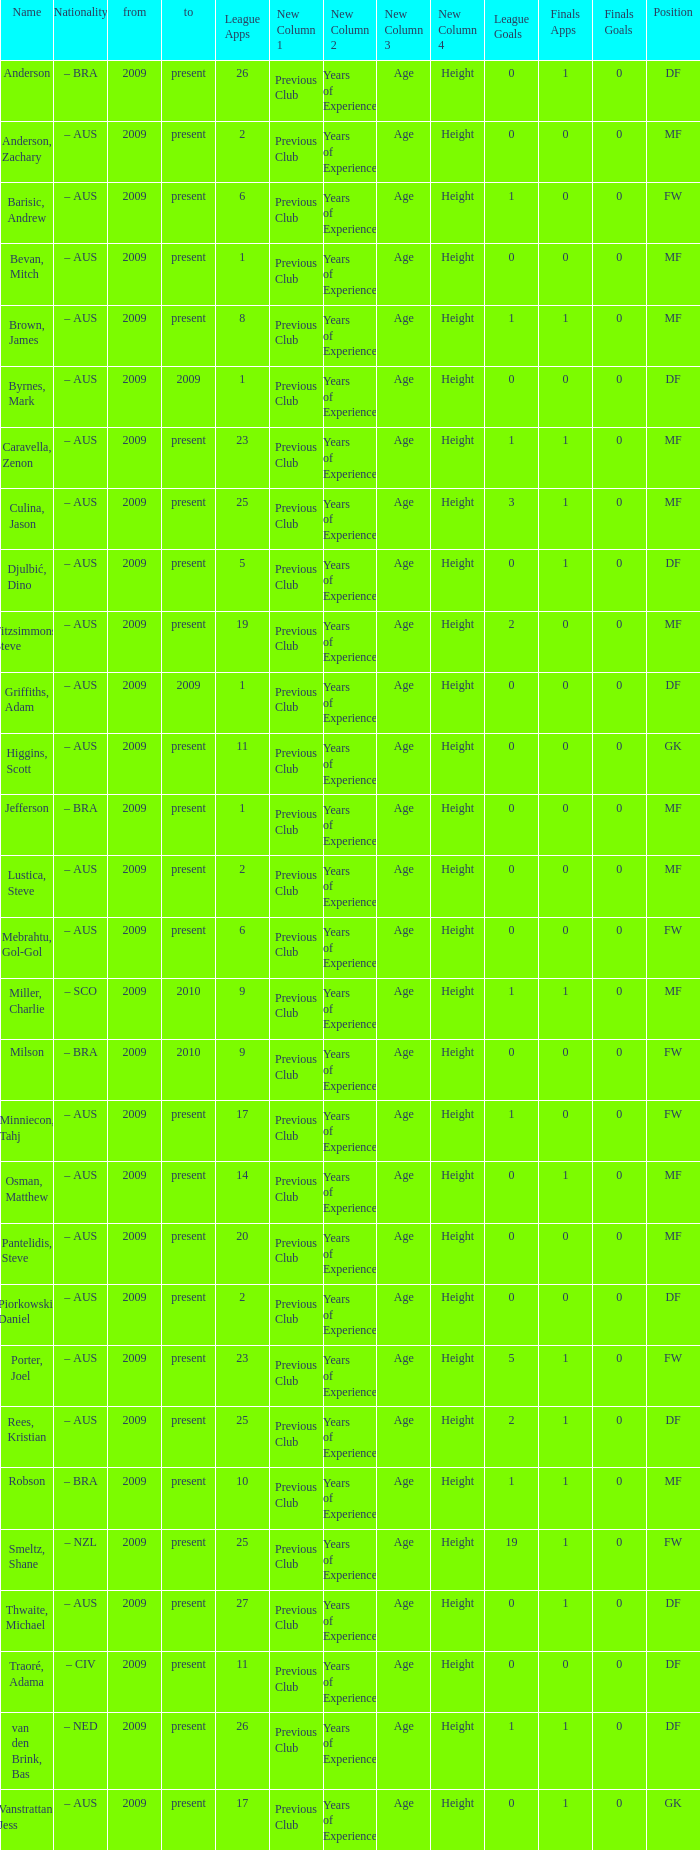Would you mind parsing the complete table? {'header': ['Name', 'Nationality', 'from', 'to', 'League Apps', 'New Column 1', 'New Column 2', 'New Column 3', 'New Column 4', 'League Goals', 'Finals Apps', 'Finals Goals', 'Position'], 'rows': [['Anderson', '– BRA', '2009', 'present', '26', 'Previous Club', 'Years of Experience', 'Age', 'Height', '0', '1', '0', 'DF'], ['Anderson, Zachary', '– AUS', '2009', 'present', '2', 'Previous Club', 'Years of Experience', 'Age', 'Height', '0', '0', '0', 'MF'], ['Barisic, Andrew', '– AUS', '2009', 'present', '6', 'Previous Club', 'Years of Experience', 'Age', 'Height', '1', '0', '0', 'FW'], ['Bevan, Mitch', '– AUS', '2009', 'present', '1', 'Previous Club', 'Years of Experience', 'Age', 'Height', '0', '0', '0', 'MF'], ['Brown, James', '– AUS', '2009', 'present', '8', 'Previous Club', 'Years of Experience', 'Age', 'Height', '1', '1', '0', 'MF'], ['Byrnes, Mark', '– AUS', '2009', '2009', '1', 'Previous Club', 'Years of Experience', 'Age', 'Height', '0', '0', '0', 'DF'], ['Caravella, Zenon', '– AUS', '2009', 'present', '23', 'Previous Club', 'Years of Experience', 'Age', 'Height', '1', '1', '0', 'MF'], ['Culina, Jason', '– AUS', '2009', 'present', '25', 'Previous Club', 'Years of Experience', 'Age', 'Height', '3', '1', '0', 'MF'], ['Djulbić, Dino', '– AUS', '2009', 'present', '5', 'Previous Club', 'Years of Experience', 'Age', 'Height', '0', '1', '0', 'DF'], ['Fitzsimmons, Steve', '– AUS', '2009', 'present', '19', 'Previous Club', 'Years of Experience', 'Age', 'Height', '2', '0', '0', 'MF'], ['Griffiths, Adam', '– AUS', '2009', '2009', '1', 'Previous Club', 'Years of Experience', 'Age', 'Height', '0', '0', '0', 'DF'], ['Higgins, Scott', '– AUS', '2009', 'present', '11', 'Previous Club', 'Years of Experience', 'Age', 'Height', '0', '0', '0', 'GK'], ['Jefferson', '– BRA', '2009', 'present', '1', 'Previous Club', 'Years of Experience', 'Age', 'Height', '0', '0', '0', 'MF'], ['Lustica, Steve', '– AUS', '2009', 'present', '2', 'Previous Club', 'Years of Experience', 'Age', 'Height', '0', '0', '0', 'MF'], ['Mebrahtu, Gol-Gol', '– AUS', '2009', 'present', '6', 'Previous Club', 'Years of Experience', 'Age', 'Height', '0', '0', '0', 'FW'], ['Miller, Charlie', '– SCO', '2009', '2010', '9', 'Previous Club', 'Years of Experience', 'Age', 'Height', '1', '1', '0', 'MF'], ['Milson', '– BRA', '2009', '2010', '9', 'Previous Club', 'Years of Experience', 'Age', 'Height', '0', '0', '0', 'FW'], ['Minniecon, Tahj', '– AUS', '2009', 'present', '17', 'Previous Club', 'Years of Experience', 'Age', 'Height', '1', '0', '0', 'FW'], ['Osman, Matthew', '– AUS', '2009', 'present', '14', 'Previous Club', 'Years of Experience', 'Age', 'Height', '0', '1', '0', 'MF'], ['Pantelidis, Steve', '– AUS', '2009', 'present', '20', 'Previous Club', 'Years of Experience', 'Age', 'Height', '0', '0', '0', 'MF'], ['Piorkowski, Daniel', '– AUS', '2009', 'present', '2', 'Previous Club', 'Years of Experience', 'Age', 'Height', '0', '0', '0', 'DF'], ['Porter, Joel', '– AUS', '2009', 'present', '23', 'Previous Club', 'Years of Experience', 'Age', 'Height', '5', '1', '0', 'FW'], ['Rees, Kristian', '– AUS', '2009', 'present', '25', 'Previous Club', 'Years of Experience', 'Age', 'Height', '2', '1', '0', 'DF'], ['Robson', '– BRA', '2009', 'present', '10', 'Previous Club', 'Years of Experience', 'Age', 'Height', '1', '1', '0', 'MF'], ['Smeltz, Shane', '– NZL', '2009', 'present', '25', 'Previous Club', 'Years of Experience', 'Age', 'Height', '19', '1', '0', 'FW'], ['Thwaite, Michael', '– AUS', '2009', 'present', '27', 'Previous Club', 'Years of Experience', 'Age', 'Height', '0', '1', '0', 'DF'], ['Traoré, Adama', '– CIV', '2009', 'present', '11', 'Previous Club', 'Years of Experience', 'Age', 'Height', '0', '0', '0', 'DF'], ['van den Brink, Bas', '– NED', '2009', 'present', '26', 'Previous Club', 'Years of Experience', 'Age', 'Height', '1', '1', '0', 'DF'], ['Vanstrattan, Jess', '– AUS', '2009', 'present', '17', 'Previous Club', 'Years of Experience', 'Age', 'Height', '0', '1', '0', 'GK']]} Name the mosst finals apps 1.0. 